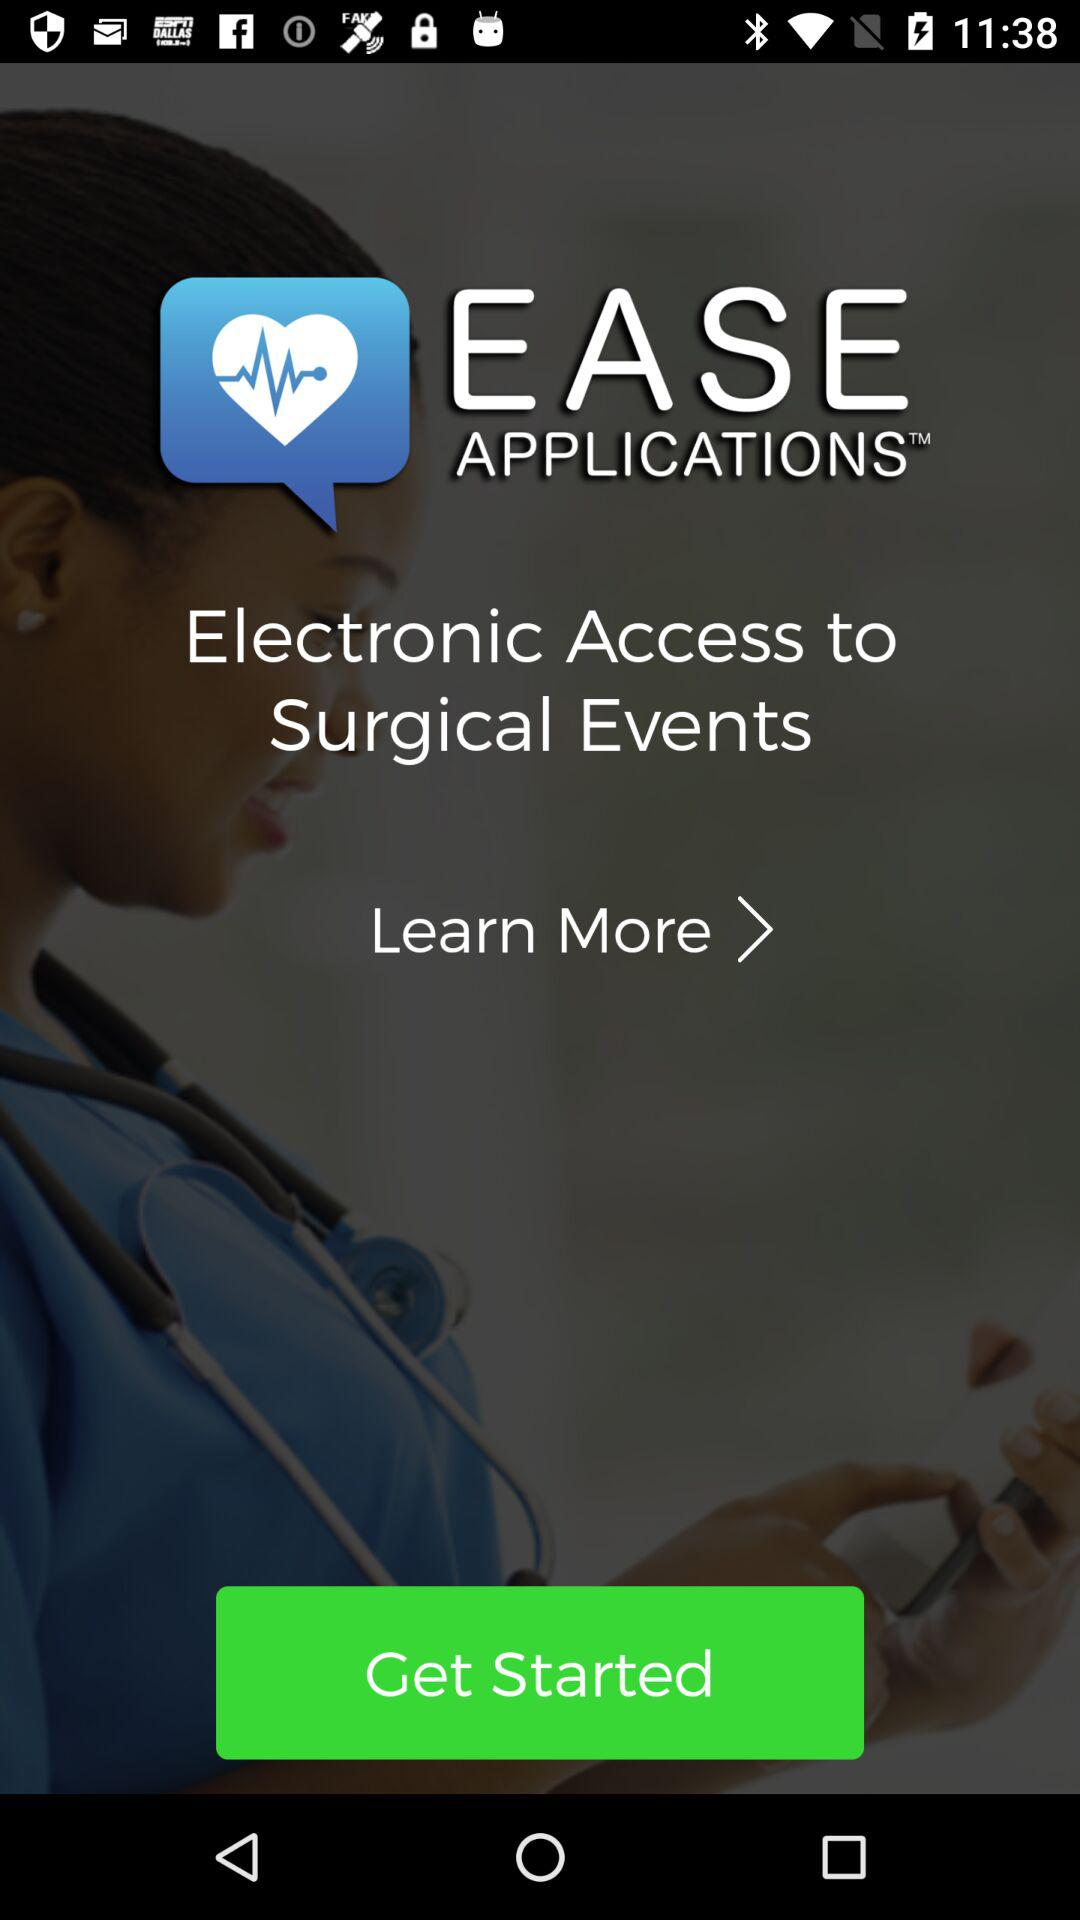What is the name of the application? The name of the application is "EASE APPLICATIONS". 